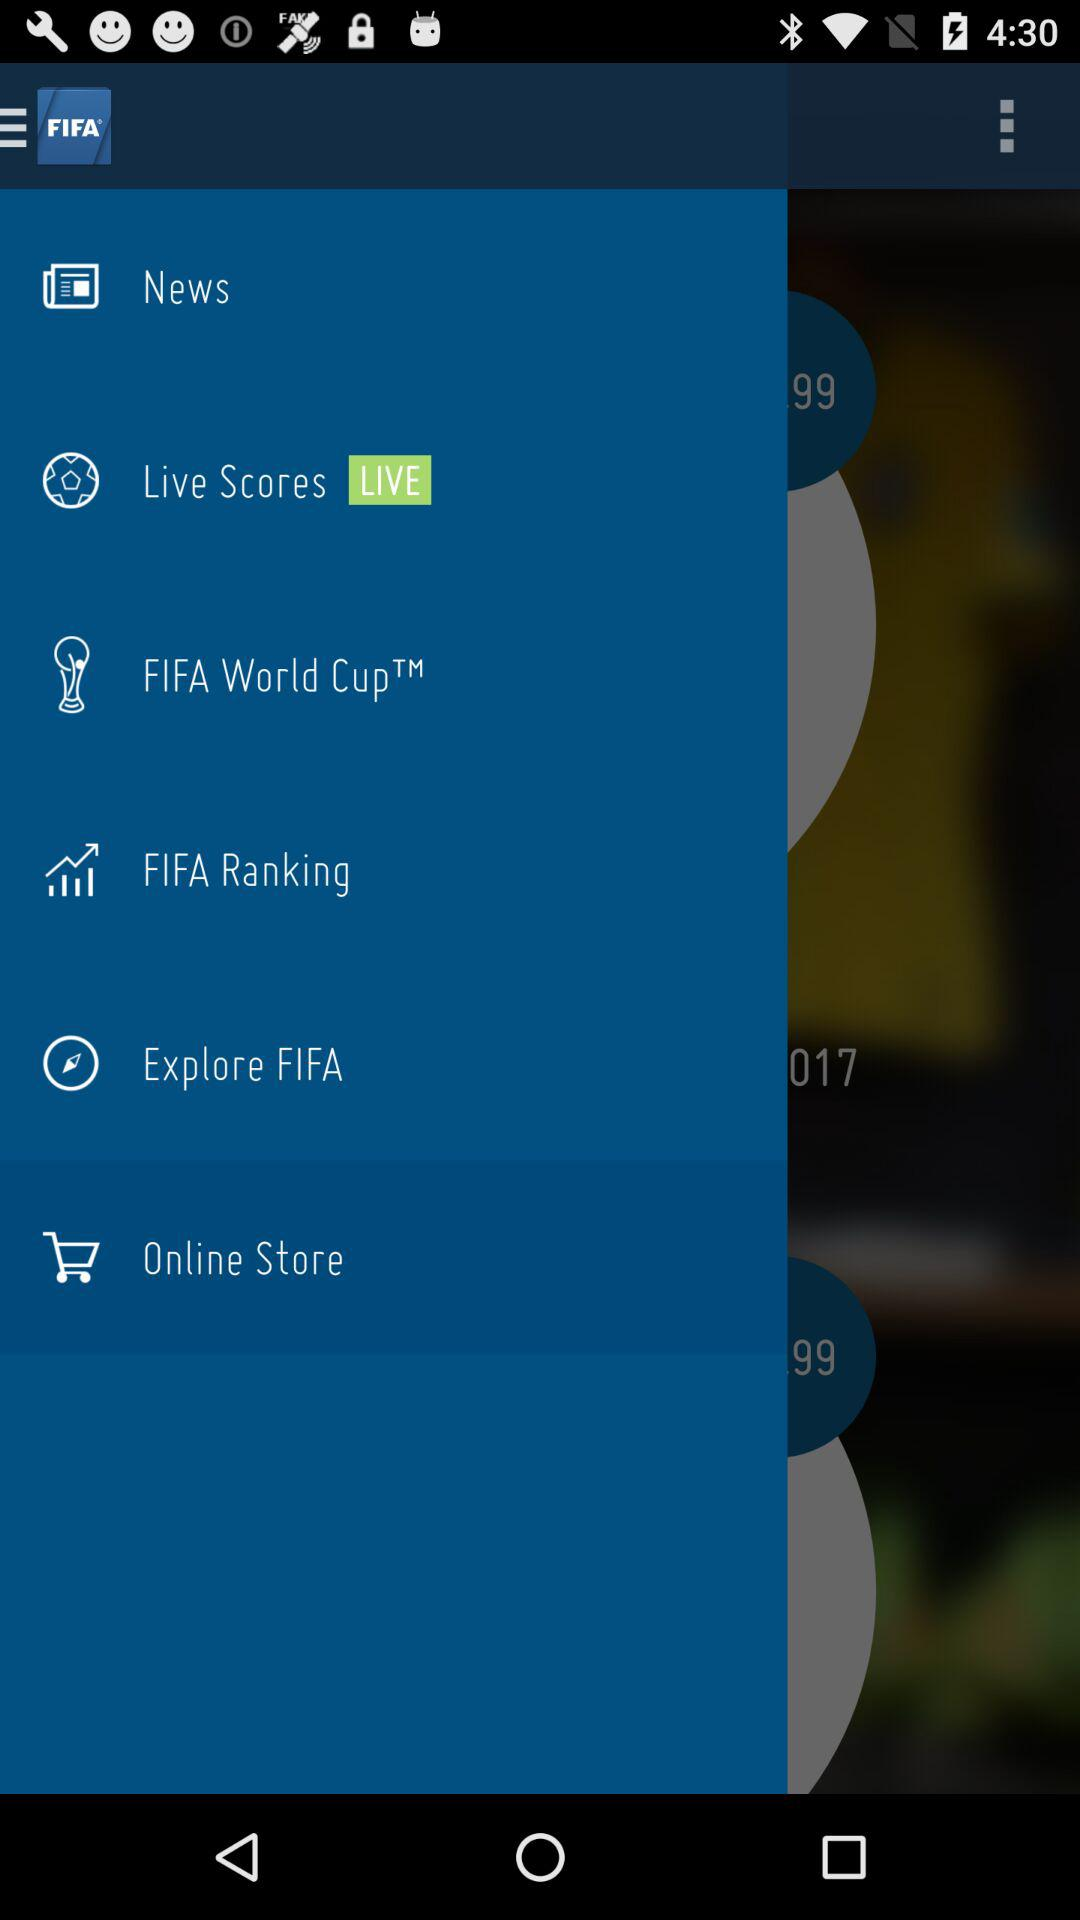Which team is at the top of the FIFA rankings?
When the provided information is insufficient, respond with <no answer>. <no answer> 